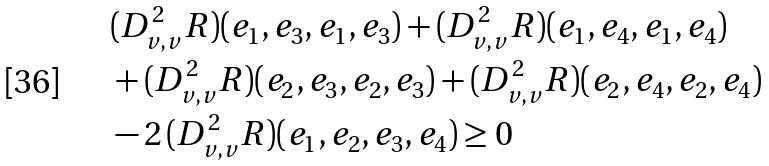<formula> <loc_0><loc_0><loc_500><loc_500>& ( D _ { v , v } ^ { 2 } R ) ( e _ { 1 } , e _ { 3 } , e _ { 1 } , e _ { 3 } ) + ( D _ { v , v } ^ { 2 } R ) ( e _ { 1 } , e _ { 4 } , e _ { 1 } , e _ { 4 } ) \\ & + ( D _ { v , v } ^ { 2 } R ) ( e _ { 2 } , e _ { 3 } , e _ { 2 } , e _ { 3 } ) + ( D _ { v , v } ^ { 2 } R ) ( e _ { 2 } , e _ { 4 } , e _ { 2 } , e _ { 4 } ) \\ & - 2 \, ( D _ { v , v } ^ { 2 } R ) ( e _ { 1 } , e _ { 2 } , e _ { 3 } , e _ { 4 } ) \geq 0</formula> 